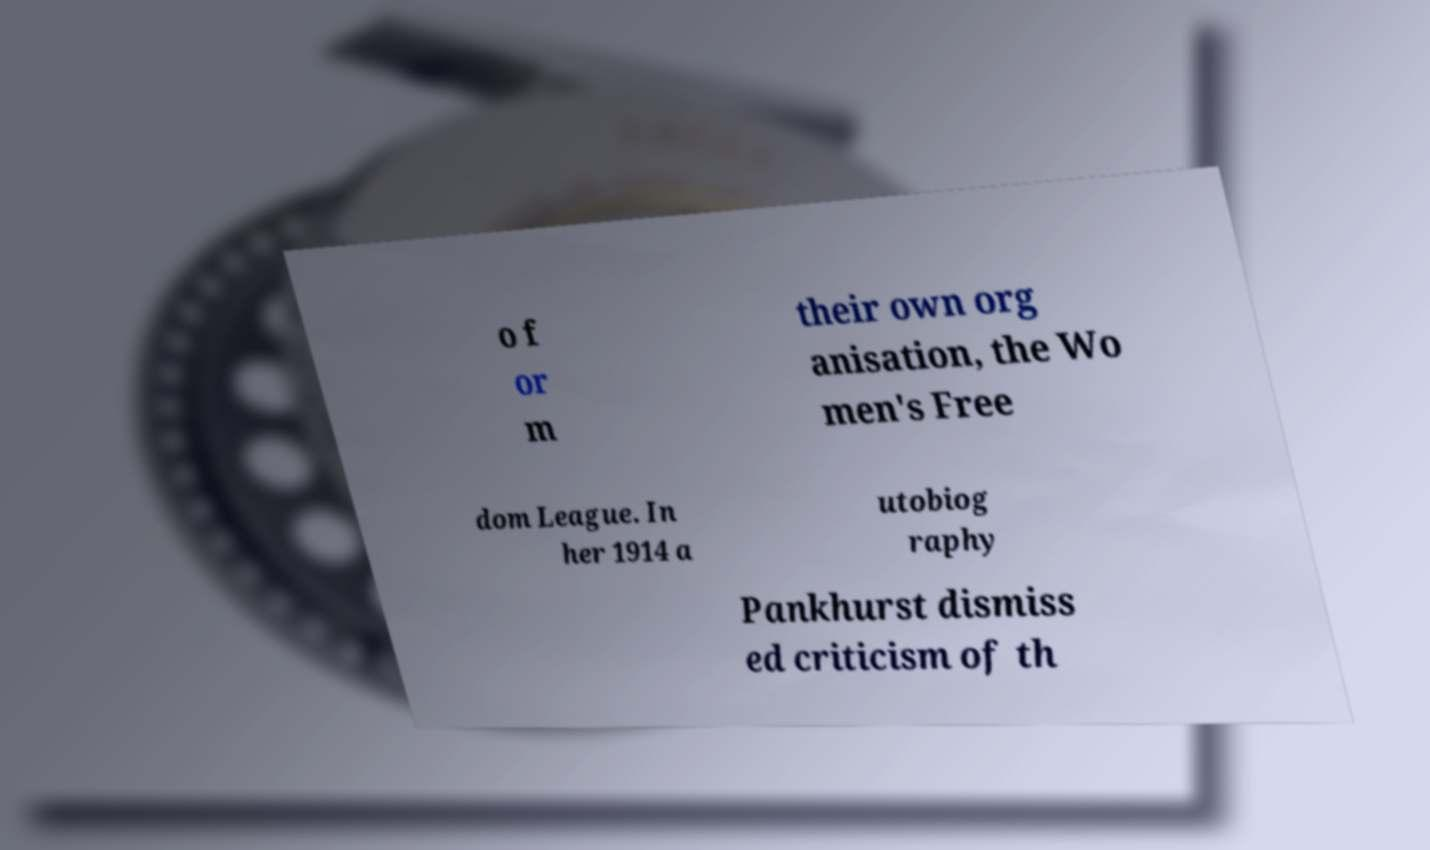What messages or text are displayed in this image? I need them in a readable, typed format. o f or m their own org anisation, the Wo men's Free dom League. In her 1914 a utobiog raphy Pankhurst dismiss ed criticism of th 